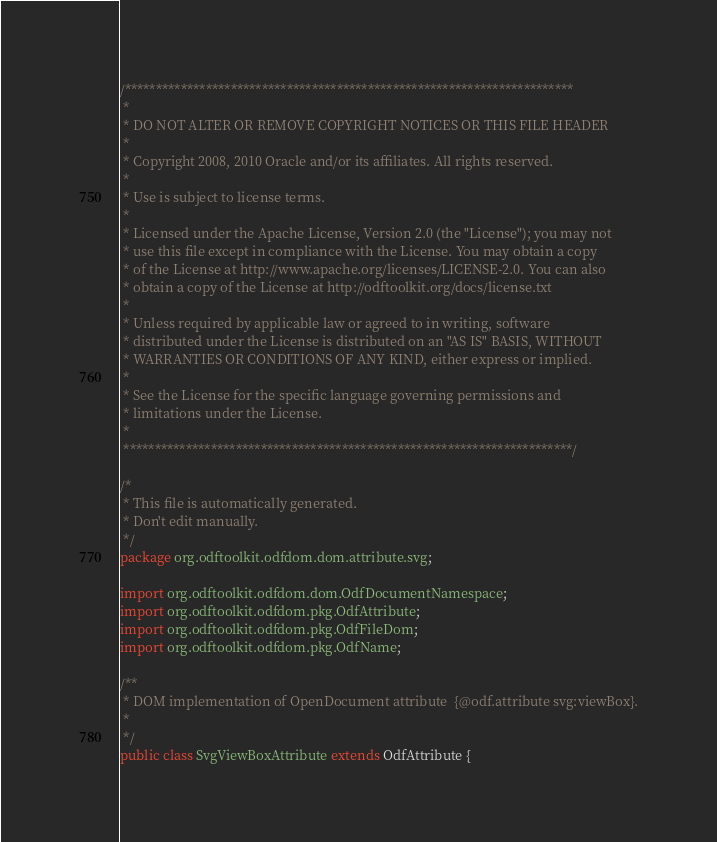Convert code to text. <code><loc_0><loc_0><loc_500><loc_500><_Java_>/************************************************************************
 *
 * DO NOT ALTER OR REMOVE COPYRIGHT NOTICES OR THIS FILE HEADER
 *
 * Copyright 2008, 2010 Oracle and/or its affiliates. All rights reserved.
 *
 * Use is subject to license terms.
 *
 * Licensed under the Apache License, Version 2.0 (the "License"); you may not
 * use this file except in compliance with the License. You may obtain a copy
 * of the License at http://www.apache.org/licenses/LICENSE-2.0. You can also
 * obtain a copy of the License at http://odftoolkit.org/docs/license.txt
 *
 * Unless required by applicable law or agreed to in writing, software
 * distributed under the License is distributed on an "AS IS" BASIS, WITHOUT
 * WARRANTIES OR CONDITIONS OF ANY KIND, either express or implied.
 *
 * See the License for the specific language governing permissions and
 * limitations under the License.
 *
 ************************************************************************/

/*
 * This file is automatically generated.
 * Don't edit manually.
 */
package org.odftoolkit.odfdom.dom.attribute.svg;

import org.odftoolkit.odfdom.dom.OdfDocumentNamespace;
import org.odftoolkit.odfdom.pkg.OdfAttribute;
import org.odftoolkit.odfdom.pkg.OdfFileDom;
import org.odftoolkit.odfdom.pkg.OdfName;

/**
 * DOM implementation of OpenDocument attribute  {@odf.attribute svg:viewBox}.
 *
 */
public class SvgViewBoxAttribute extends OdfAttribute {
</code> 